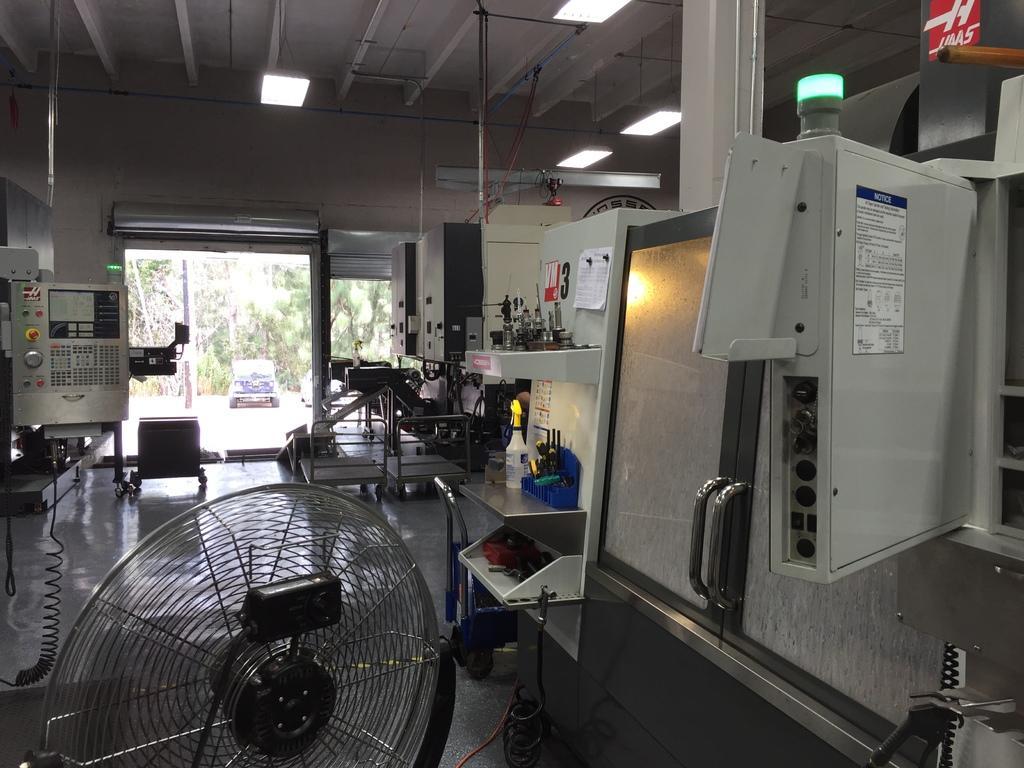Could you give a brief overview of what you see in this image? In this image we can see some electronic devices with wires. We can also see some papers pinned to a wall, a group of trees, cloth, a container and some tools placed on the shelves, a lamp and some trolleys placed on the floor. We can also see a wall, pillar and a roof with some ceiling lights. On the backside we can see a pole, group of trees and a car parked aside. 